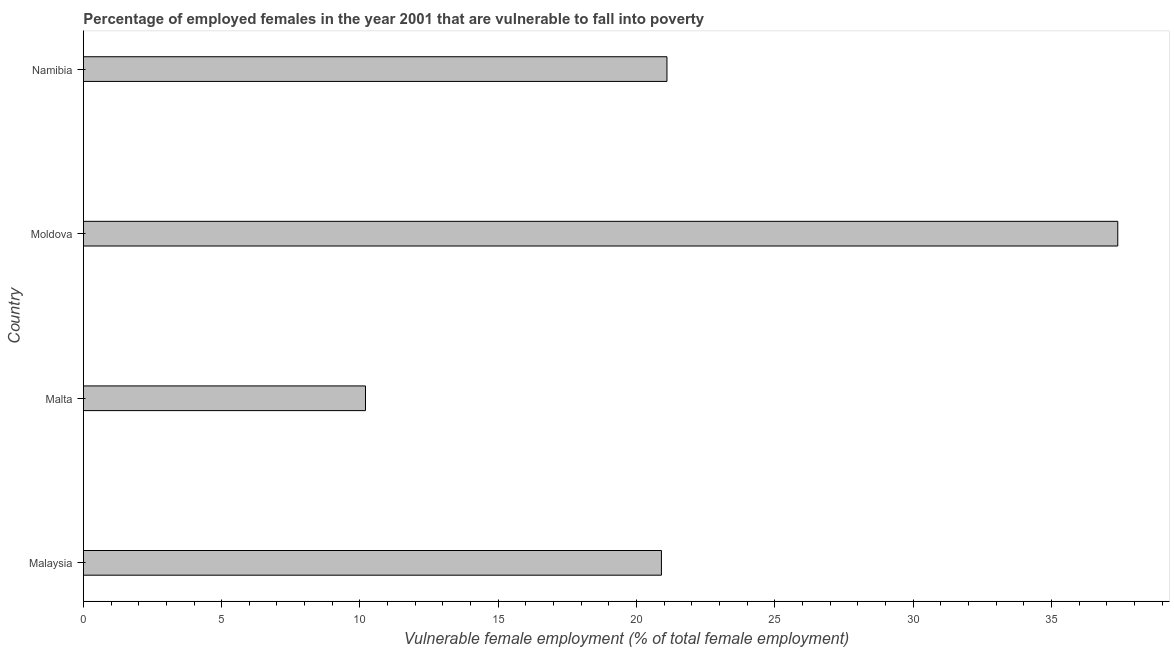Does the graph contain any zero values?
Your response must be concise. No. Does the graph contain grids?
Give a very brief answer. No. What is the title of the graph?
Your answer should be very brief. Percentage of employed females in the year 2001 that are vulnerable to fall into poverty. What is the label or title of the X-axis?
Offer a terse response. Vulnerable female employment (% of total female employment). What is the percentage of employed females who are vulnerable to fall into poverty in Moldova?
Offer a terse response. 37.4. Across all countries, what is the maximum percentage of employed females who are vulnerable to fall into poverty?
Make the answer very short. 37.4. Across all countries, what is the minimum percentage of employed females who are vulnerable to fall into poverty?
Make the answer very short. 10.2. In which country was the percentage of employed females who are vulnerable to fall into poverty maximum?
Offer a terse response. Moldova. In which country was the percentage of employed females who are vulnerable to fall into poverty minimum?
Make the answer very short. Malta. What is the sum of the percentage of employed females who are vulnerable to fall into poverty?
Your answer should be compact. 89.6. What is the average percentage of employed females who are vulnerable to fall into poverty per country?
Give a very brief answer. 22.4. What is the median percentage of employed females who are vulnerable to fall into poverty?
Your answer should be compact. 21. In how many countries, is the percentage of employed females who are vulnerable to fall into poverty greater than 10 %?
Keep it short and to the point. 4. What is the ratio of the percentage of employed females who are vulnerable to fall into poverty in Moldova to that in Namibia?
Give a very brief answer. 1.77. Is the percentage of employed females who are vulnerable to fall into poverty in Malaysia less than that in Namibia?
Your response must be concise. Yes. Is the difference between the percentage of employed females who are vulnerable to fall into poverty in Malaysia and Moldova greater than the difference between any two countries?
Make the answer very short. No. What is the difference between the highest and the second highest percentage of employed females who are vulnerable to fall into poverty?
Offer a terse response. 16.3. Is the sum of the percentage of employed females who are vulnerable to fall into poverty in Malaysia and Moldova greater than the maximum percentage of employed females who are vulnerable to fall into poverty across all countries?
Keep it short and to the point. Yes. What is the difference between the highest and the lowest percentage of employed females who are vulnerable to fall into poverty?
Provide a short and direct response. 27.2. How many bars are there?
Give a very brief answer. 4. Are all the bars in the graph horizontal?
Provide a short and direct response. Yes. What is the Vulnerable female employment (% of total female employment) in Malaysia?
Offer a very short reply. 20.9. What is the Vulnerable female employment (% of total female employment) of Malta?
Provide a succinct answer. 10.2. What is the Vulnerable female employment (% of total female employment) of Moldova?
Provide a succinct answer. 37.4. What is the Vulnerable female employment (% of total female employment) in Namibia?
Your answer should be compact. 21.1. What is the difference between the Vulnerable female employment (% of total female employment) in Malaysia and Moldova?
Make the answer very short. -16.5. What is the difference between the Vulnerable female employment (% of total female employment) in Malaysia and Namibia?
Keep it short and to the point. -0.2. What is the difference between the Vulnerable female employment (% of total female employment) in Malta and Moldova?
Your answer should be very brief. -27.2. What is the difference between the Vulnerable female employment (% of total female employment) in Malta and Namibia?
Offer a very short reply. -10.9. What is the ratio of the Vulnerable female employment (% of total female employment) in Malaysia to that in Malta?
Provide a succinct answer. 2.05. What is the ratio of the Vulnerable female employment (% of total female employment) in Malaysia to that in Moldova?
Your answer should be very brief. 0.56. What is the ratio of the Vulnerable female employment (% of total female employment) in Malta to that in Moldova?
Offer a very short reply. 0.27. What is the ratio of the Vulnerable female employment (% of total female employment) in Malta to that in Namibia?
Offer a terse response. 0.48. What is the ratio of the Vulnerable female employment (% of total female employment) in Moldova to that in Namibia?
Ensure brevity in your answer.  1.77. 